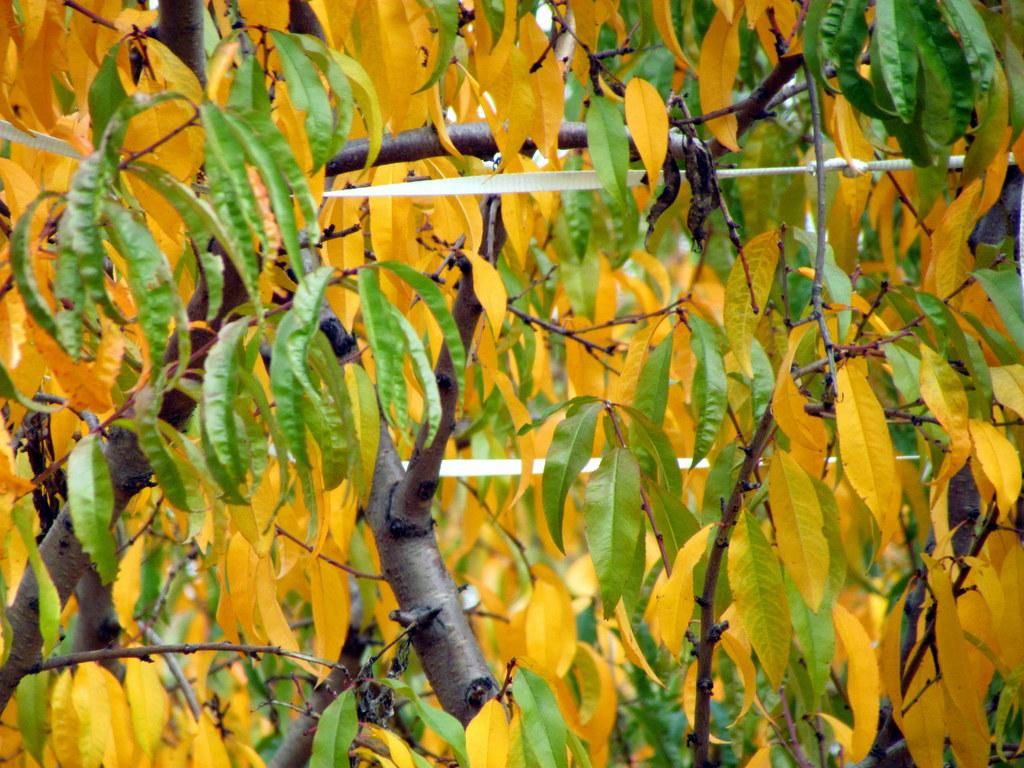What color are some of the leaves in the image? There are yellow leaves in the image. What color are the other leaves in the image? There are green leaves in the image. What can be seen in the background of the image? There are trees in the background of the image. What type of zinc is present in the image? There is no zinc present in the image; it features leaves and trees. How many snakes can be seen slithering through the leaves in the image? There are no snakes present in the image; it only features leaves and trees. 